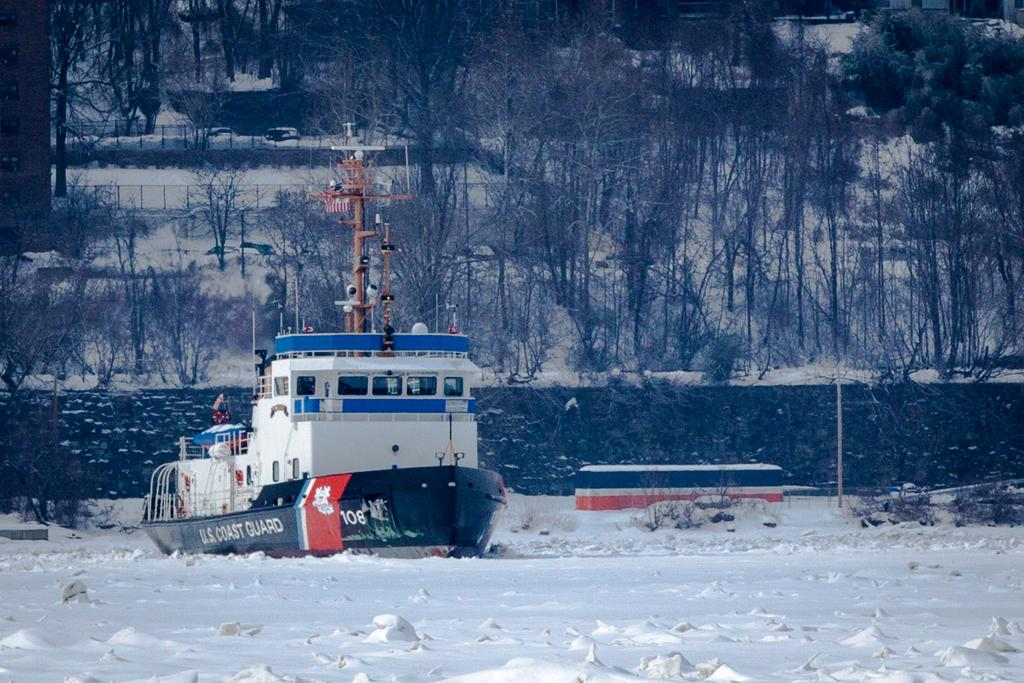What is the main subject of the image? There is a boat in the image. What else can be seen in the image besides the boat? There is a wall, a pole, trees, and a fence in the image. What is the overall condition of the environment in the image? The image is covered in snow, which is white in color. What type of mint can be seen growing near the boat in the image? There is no mint visible in the image, as the environment is covered in snow. Can you tell me how many aunts are present in the image? There are no people, including aunts, present in the image; it features a boat and other objects in a snowy environment. 